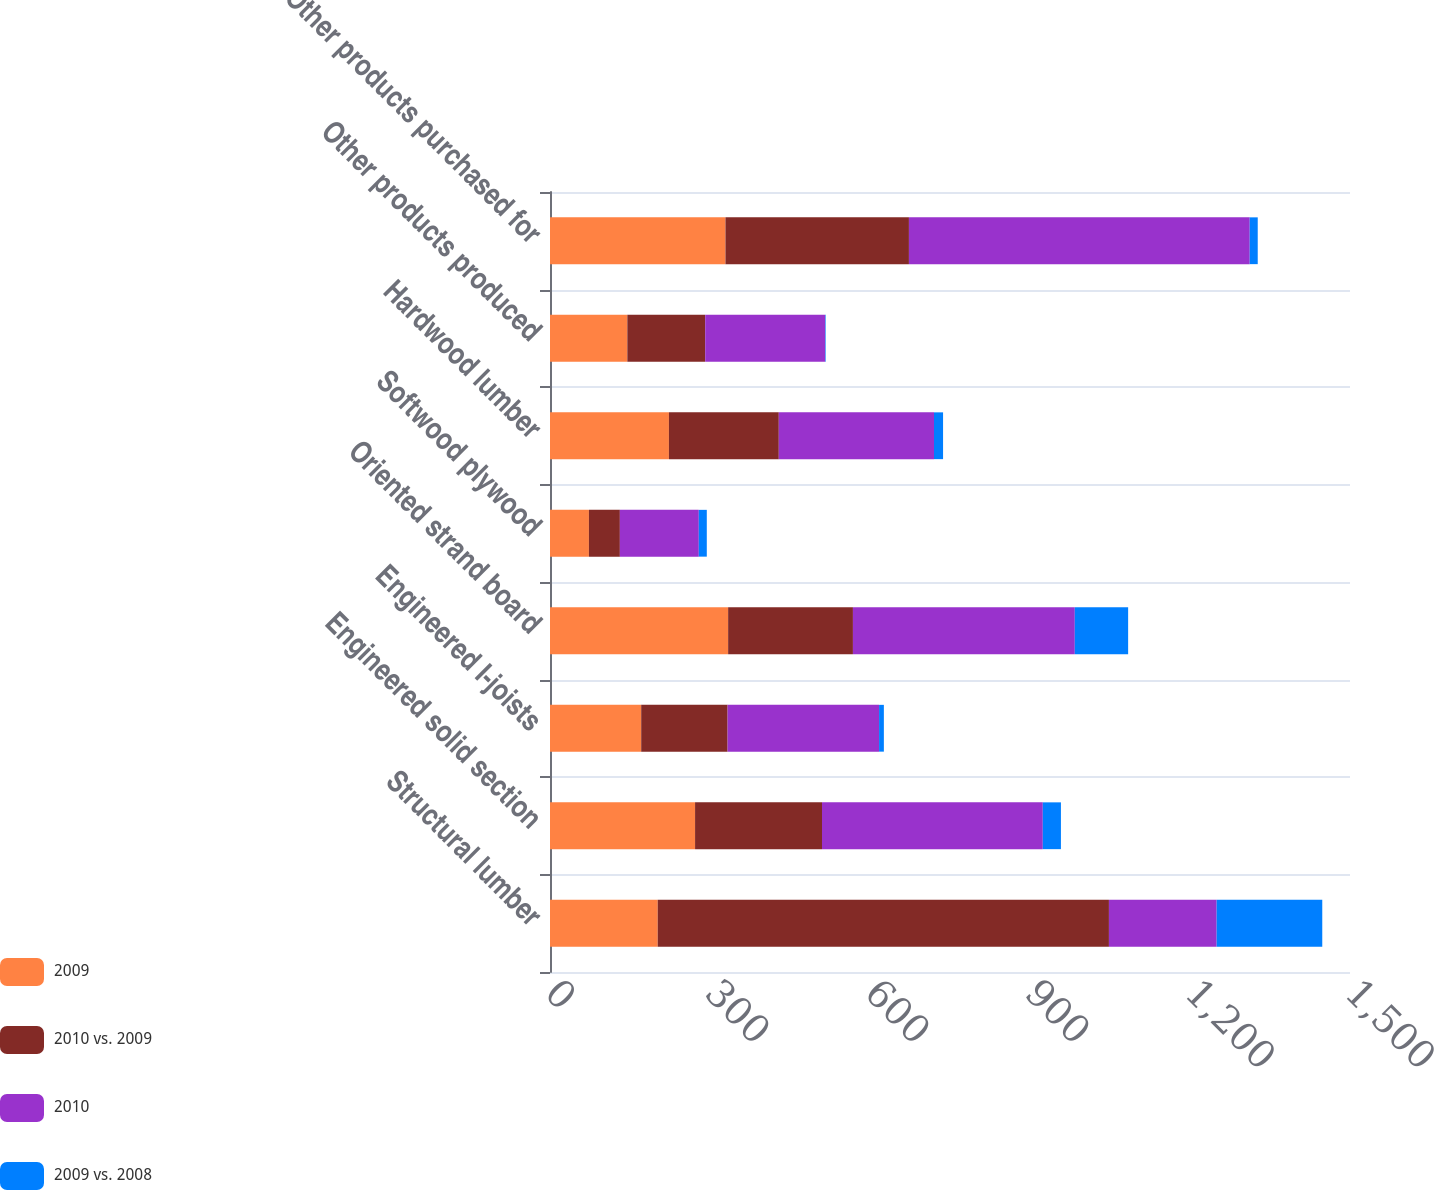Convert chart. <chart><loc_0><loc_0><loc_500><loc_500><stacked_bar_chart><ecel><fcel>Structural lumber<fcel>Engineered solid section<fcel>Engineered I-joists<fcel>Oriented strand board<fcel>Softwood plywood<fcel>Hardwood lumber<fcel>Other products produced<fcel>Other products purchased for<nl><fcel>2009<fcel>202<fcel>272<fcel>171<fcel>334<fcel>73<fcel>223<fcel>145<fcel>329<nl><fcel>2010 vs. 2009<fcel>846<fcel>238<fcel>162<fcel>234<fcel>58<fcel>206<fcel>146<fcel>344<nl><fcel>2010<fcel>202<fcel>414<fcel>284<fcel>416<fcel>148<fcel>291<fcel>225<fcel>639<nl><fcel>2009 vs. 2008<fcel>198<fcel>34<fcel>9<fcel>100<fcel>15<fcel>17<fcel>1<fcel>15<nl></chart> 